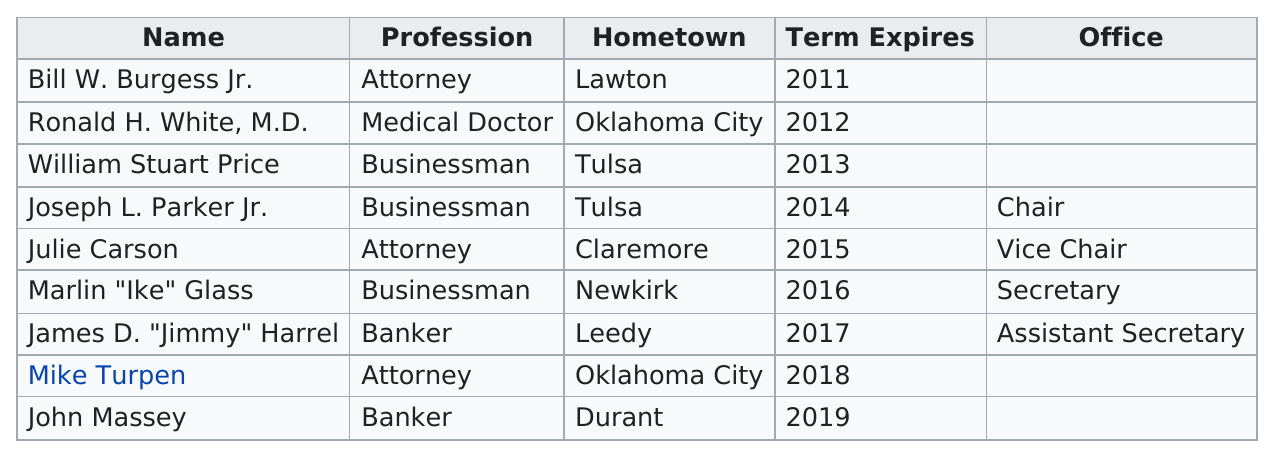Highlight a few significant elements in this photo. The current number of state regents who are bankers is 2. The only individual eligible to hold the position of regent on the state board, who must be a medical doctor, is Ronald H. White, M.D. There are a total of three members, one from Lawton and the other two from Oklahoma City. Four of the current state regents hold listed office titles. Of the members who listed businessman as their profession, there were three. 